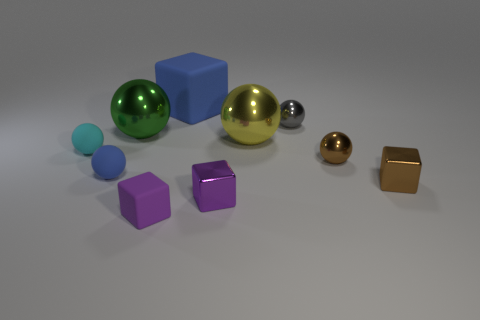What is the shape of the other matte object that is the same color as the large matte thing?
Provide a succinct answer. Sphere. What number of other things are there of the same size as the gray shiny sphere?
Offer a terse response. 6. What color is the rubber object that is in front of the small thing that is right of the small brown thing behind the small blue rubber thing?
Keep it short and to the point. Purple. The small metallic thing that is to the right of the big yellow object and in front of the small blue rubber thing has what shape?
Give a very brief answer. Cube. What number of other things are there of the same shape as the small gray object?
Give a very brief answer. 5. There is a blue rubber thing right of the purple block left of the blue thing right of the large green sphere; what shape is it?
Your answer should be very brief. Cube. How many objects are either red shiny spheres or spheres in front of the small cyan object?
Make the answer very short. 2. Do the green shiny thing that is on the right side of the blue ball and the blue object that is in front of the big green metallic sphere have the same shape?
Give a very brief answer. Yes. How many objects are either big yellow rubber cylinders or metallic spheres?
Offer a terse response. 4. Is there any other thing that has the same material as the gray ball?
Ensure brevity in your answer.  Yes. 